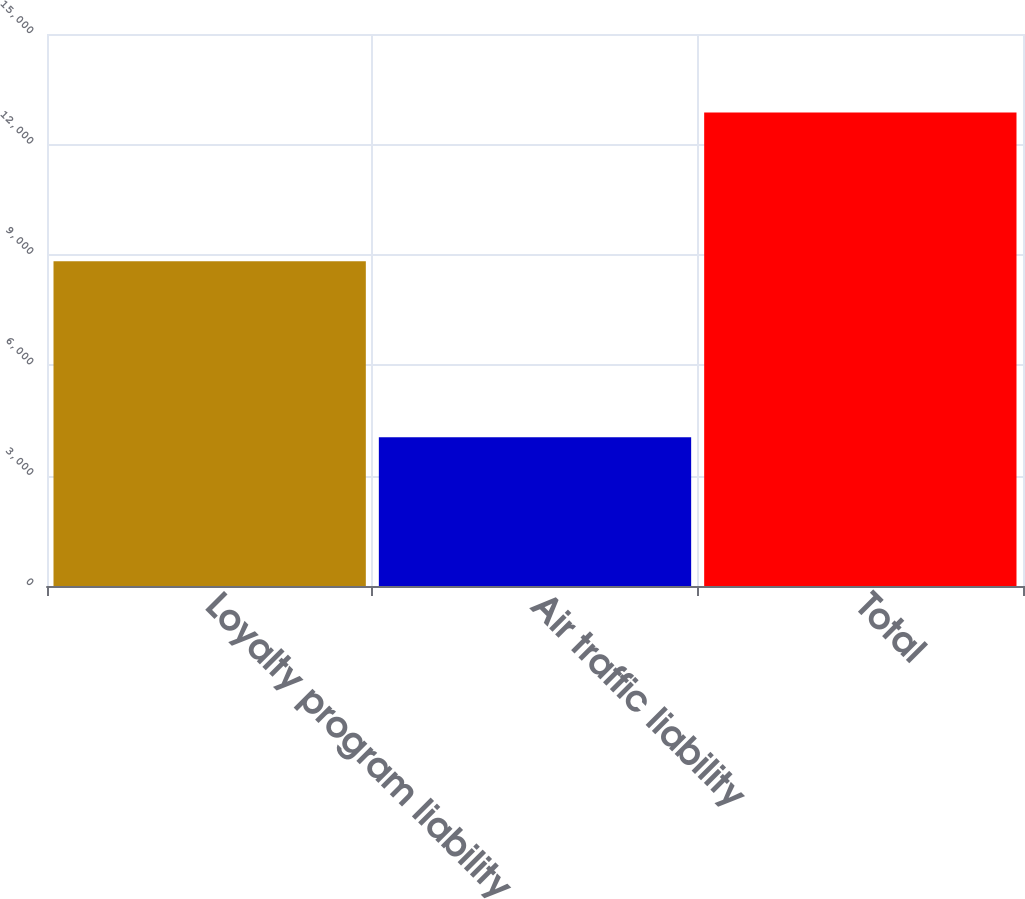Convert chart to OTSL. <chart><loc_0><loc_0><loc_500><loc_500><bar_chart><fcel>Loyalty program liability<fcel>Air traffic liability<fcel>Total<nl><fcel>8822<fcel>4042<fcel>12864<nl></chart> 